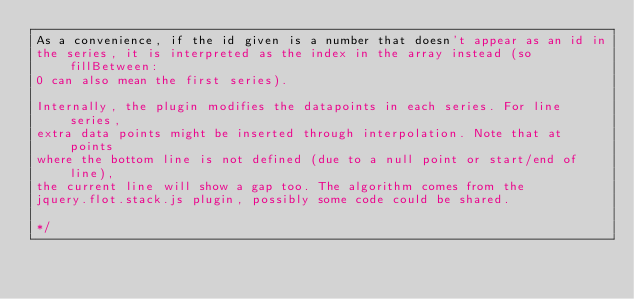<code> <loc_0><loc_0><loc_500><loc_500><_JavaScript_>As a convenience, if the id given is a number that doesn't appear as an id in
the series, it is interpreted as the index in the array instead (so fillBetween:
0 can also mean the first series).

Internally, the plugin modifies the datapoints in each series. For line series,
extra data points might be inserted through interpolation. Note that at points
where the bottom line is not defined (due to a null point or start/end of line),
the current line will show a gap too. The algorithm comes from the
jquery.flot.stack.js plugin, possibly some code could be shared.

*/
</code> 